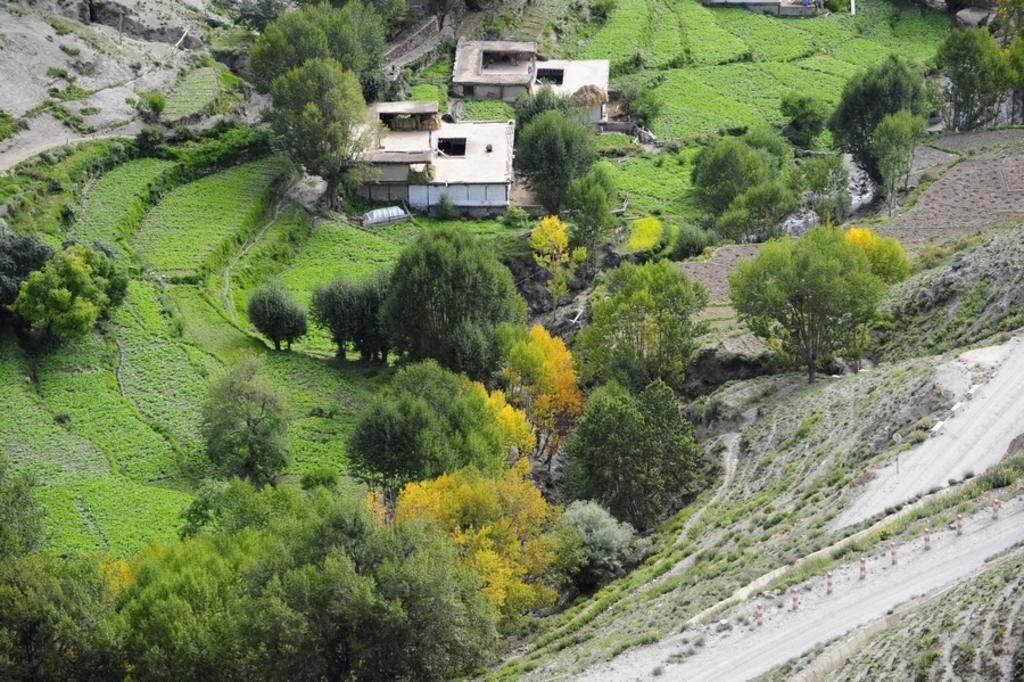Please provide a concise description of this image. This image is clicked from the top view. At the bottom, we can see many trees and plants. And there is green grass on the ground. In the middle, there are two houses. 